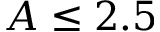<formula> <loc_0><loc_0><loc_500><loc_500>A \leq 2 . 5</formula> 